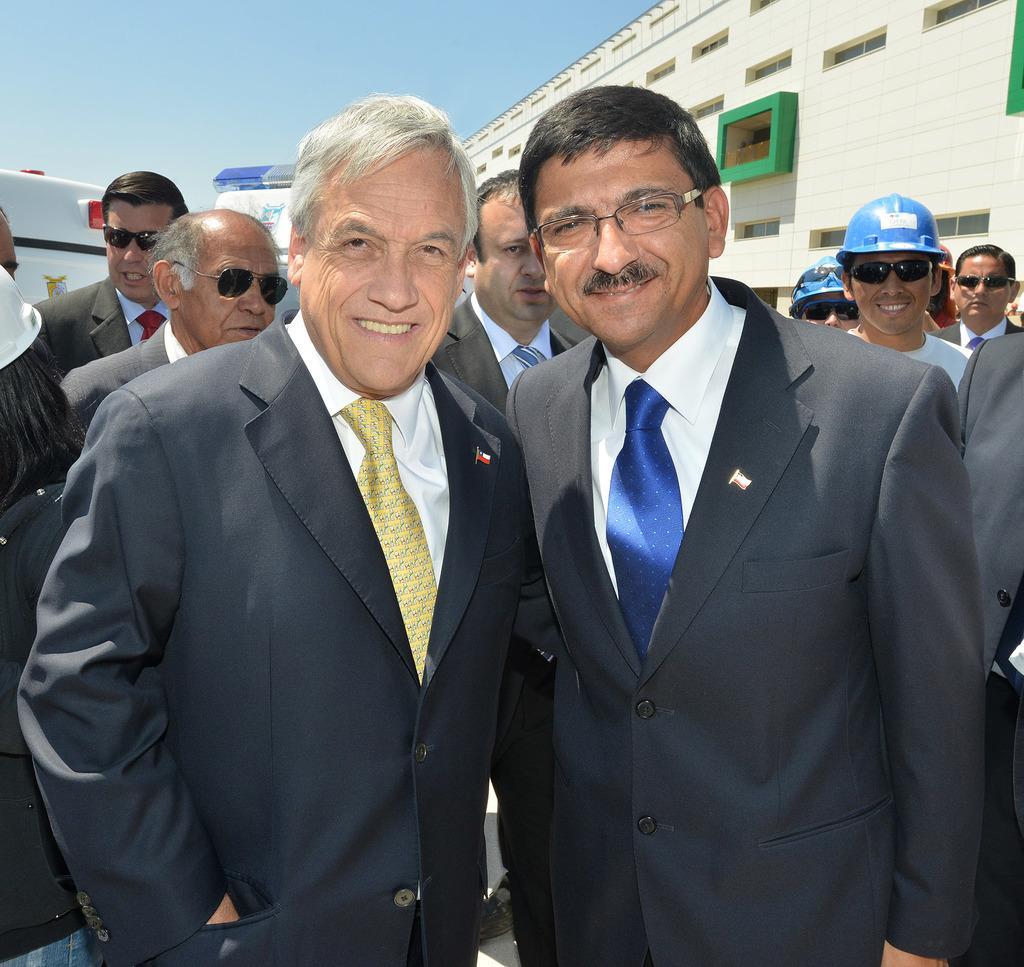Please provide a concise description of this image. In this image I can see the group of people with different color dresses. I can see few people with helmets and few people with goggles. In the background I can see the the building, few vehicles and the sky. 